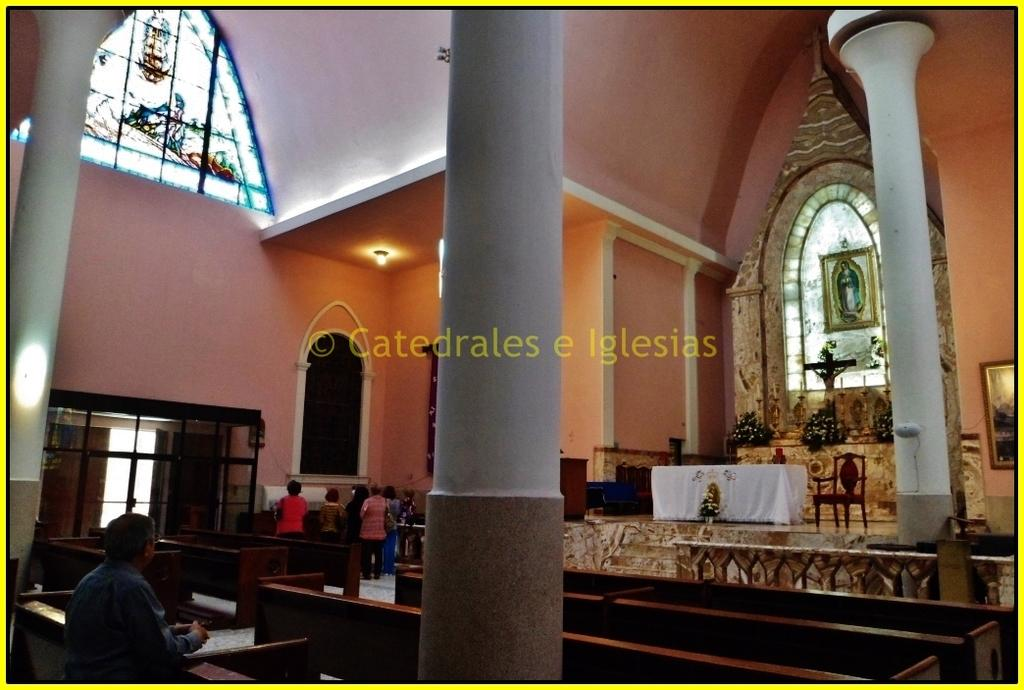What type of building is in the image? There is a church in the image. What are some features of the church? The church has windows, walls, pillars, and a table. Can you describe the lighting in the image? There is light visible in the image. Are there any people present in the image? Yes, there are people in the image. What type of seating is available in the church? There are benches in the image. What decorative items can be seen in the image? There are bouquets in the image. What type of furniture is present in the image? There is a chair in the image. What type of artwork is in the image? There is a statue in the image. What type of framing is present in the image? There is a frame in the image. What type of cream is being served in the jar on the table in the image? There is no jar or cream present in the image. 